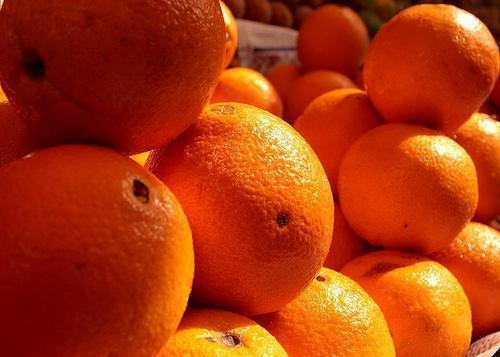What fruit is in the picture?
Indicate the correct response and explain using: 'Answer: answer
Rationale: rationale.'
Options: Mangos, apples, peaches, oranges. Answer: oranges.
Rationale: This fruit is the same color. 